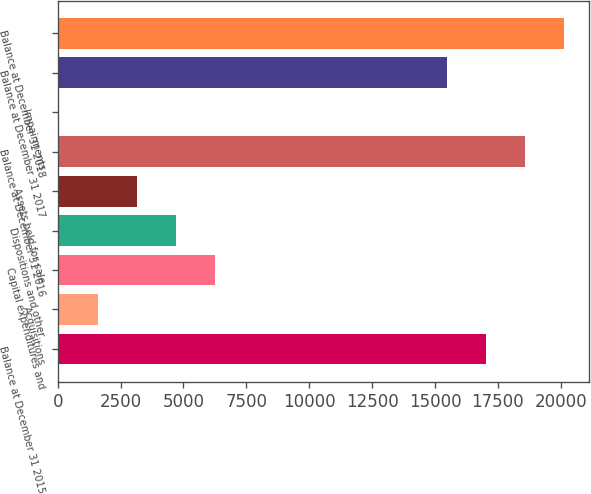Convert chart to OTSL. <chart><loc_0><loc_0><loc_500><loc_500><bar_chart><fcel>Balance at December 31 2015<fcel>Acquisitions<fcel>Capital expenditures and<fcel>Dispositions and other<fcel>Assets held for sale<fcel>Balance at December 31 2016<fcel>Impairments<fcel>Balance at December 31 2017<fcel>Balance at December 31 2018<nl><fcel>17013.3<fcel>1593.3<fcel>6244.2<fcel>4693.9<fcel>3143.6<fcel>18563.6<fcel>43<fcel>15463<fcel>20113.9<nl></chart> 